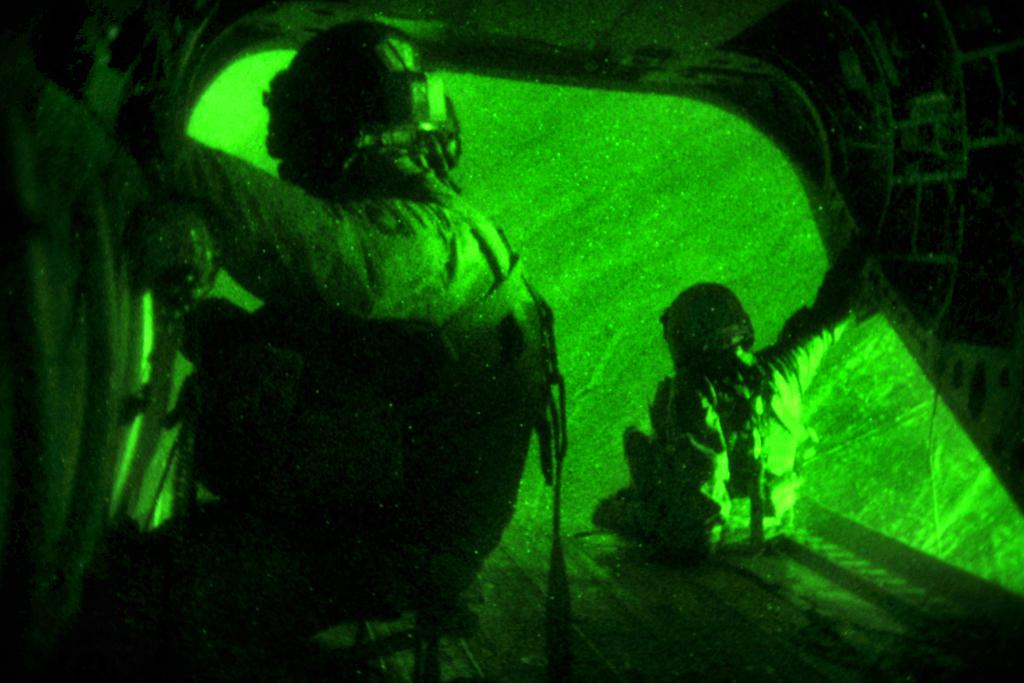How many people are in the image? There are two persons in the image. What are the persons doing in the image? The persons are sitting. What are the persons wearing on their heads? The persons are wearing helmets. What color light is visible in the background of the image? There is green color light in the background of the image. What can be seen in the background of the image besides the green light? There are objects in the background of the image. What type of root can be seen growing from the helmets in the image? There is no root growing from the helmets in the image. What kind of marble is visible on the ground in the image? There is no marble visible on the ground in the image. 